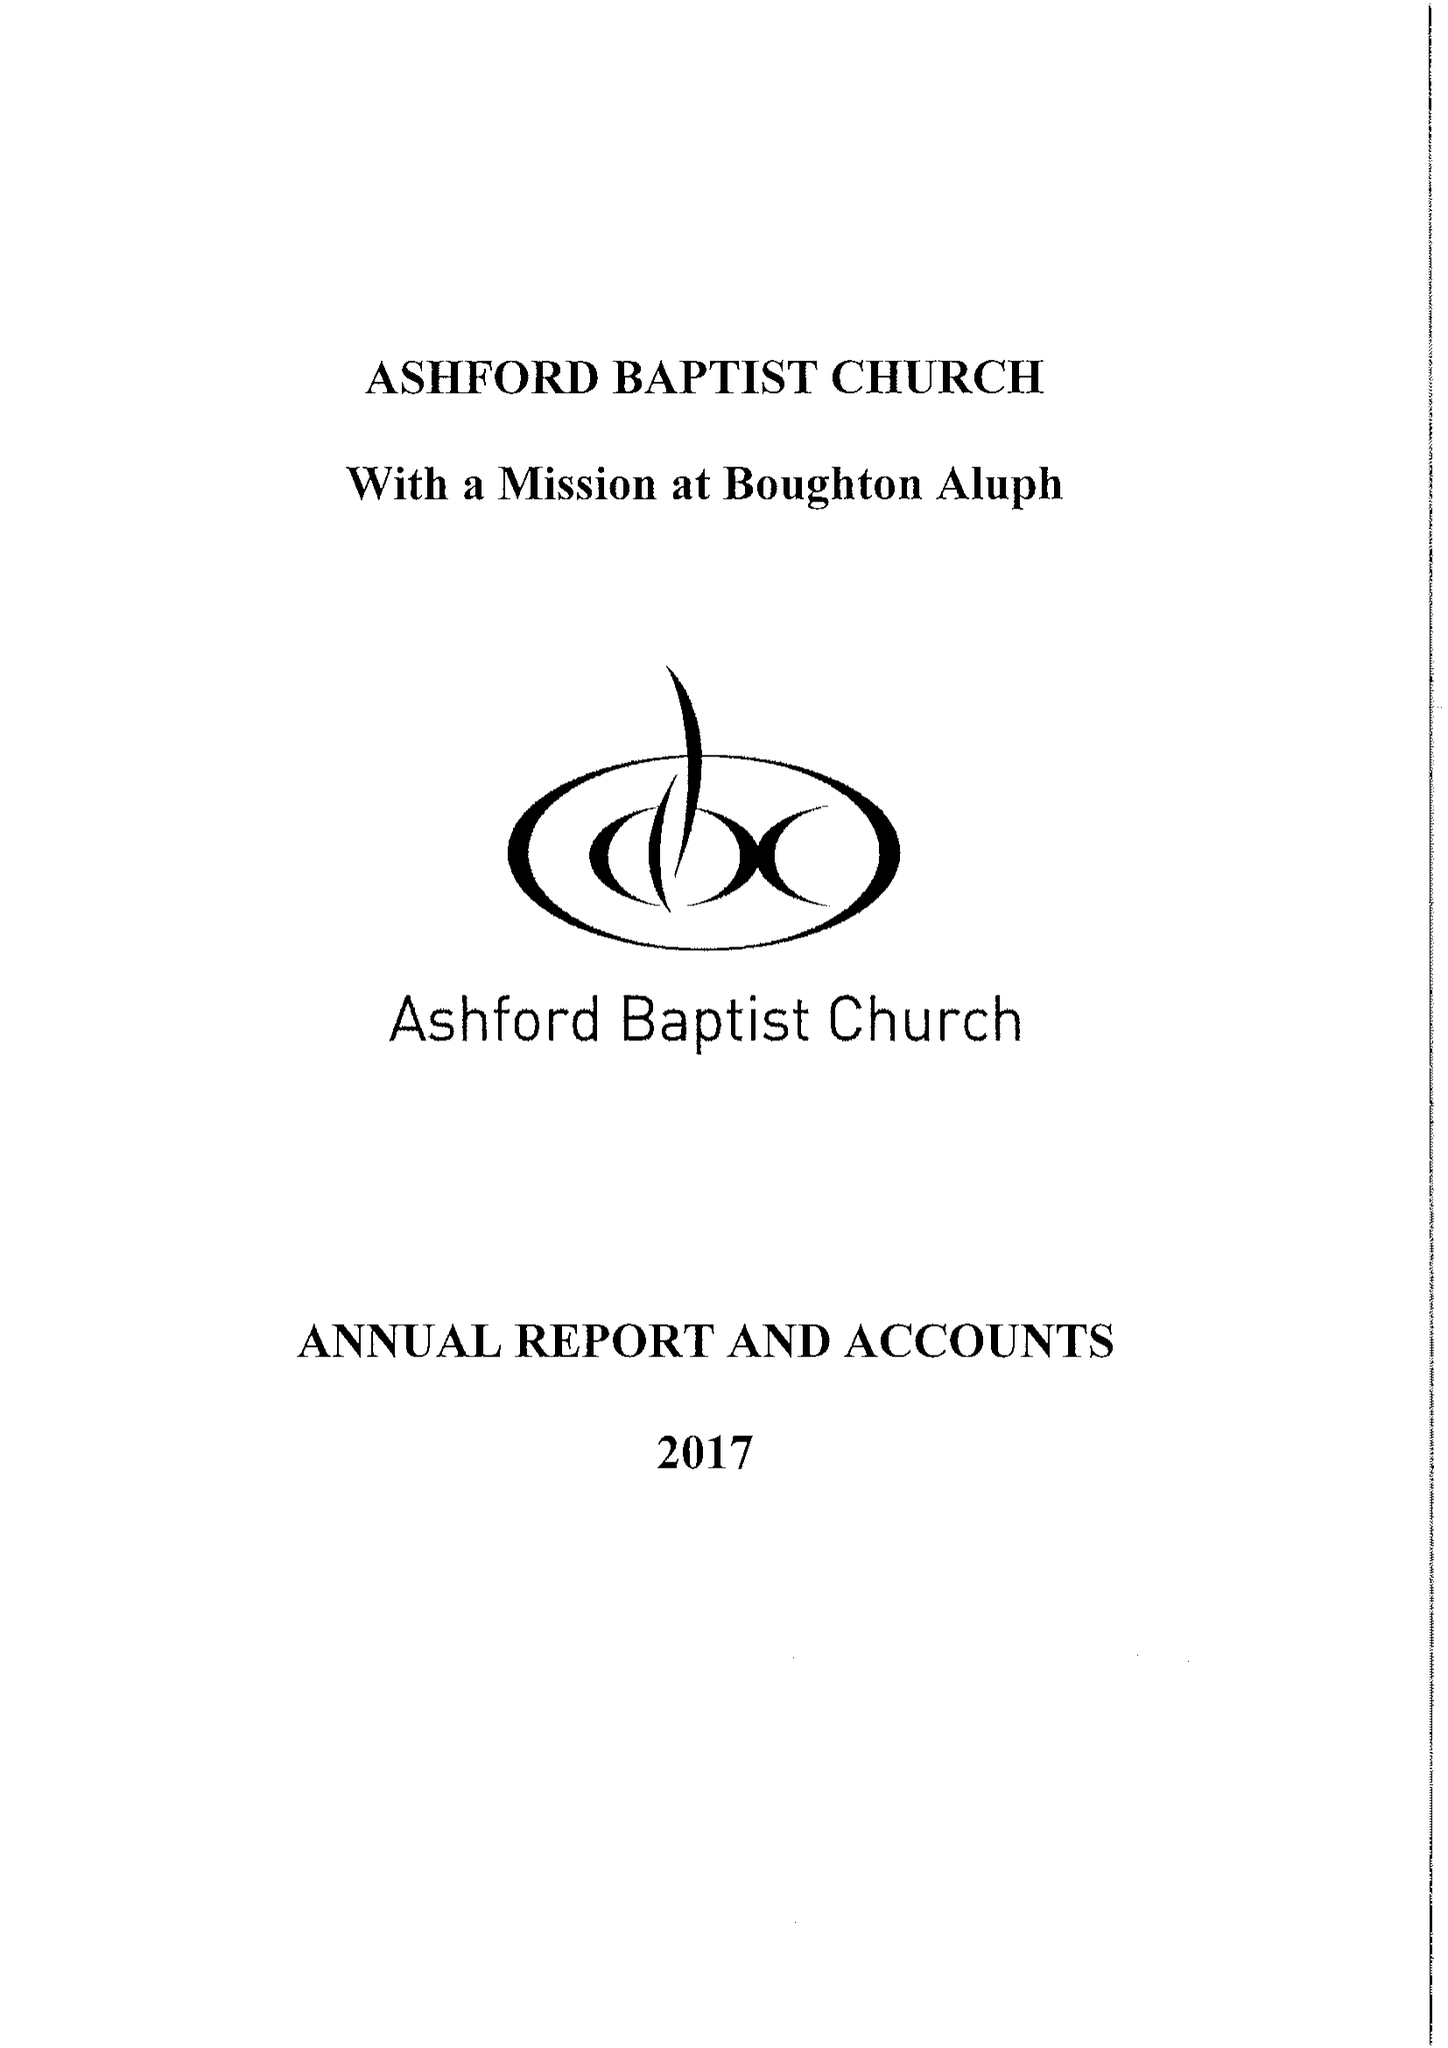What is the value for the address__street_line?
Answer the question using a single word or phrase. ST. JOHNS LANE 